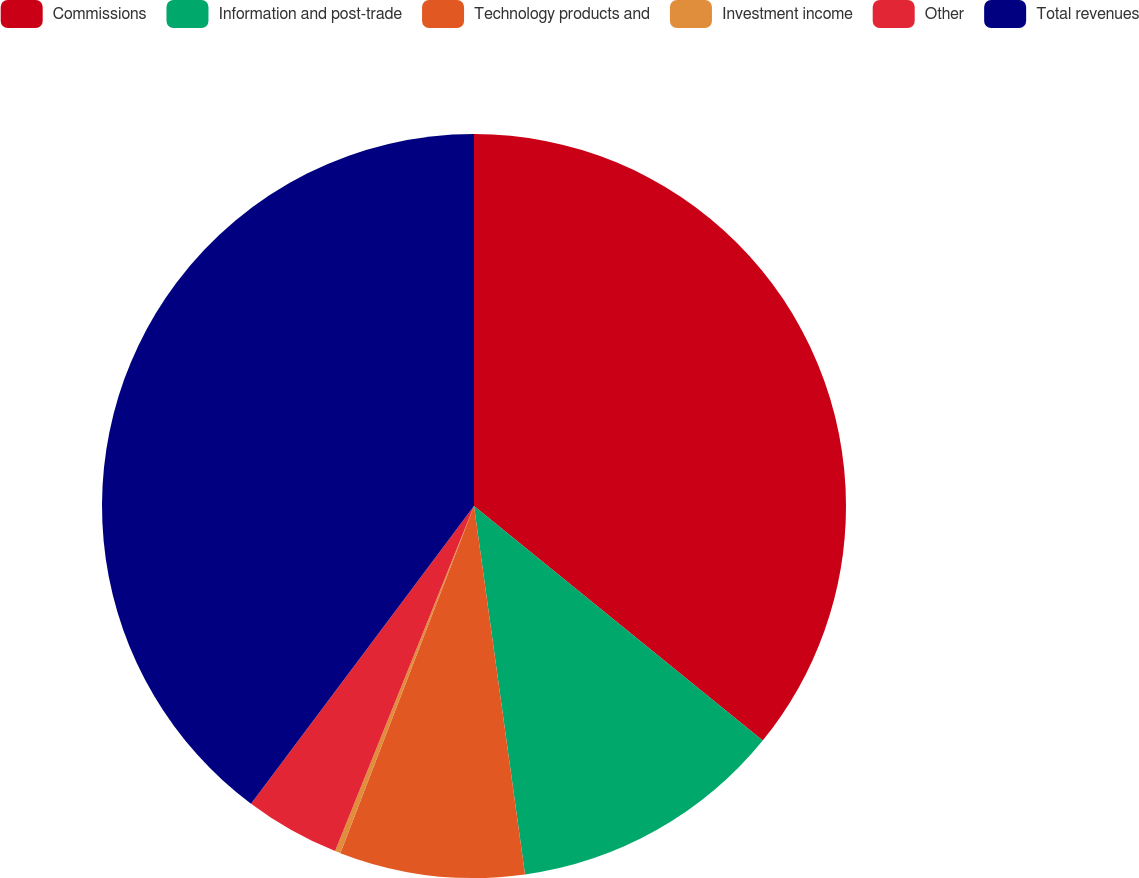<chart> <loc_0><loc_0><loc_500><loc_500><pie_chart><fcel>Commissions<fcel>Information and post-trade<fcel>Technology products and<fcel>Investment income<fcel>Other<fcel>Total revenues<nl><fcel>35.86%<fcel>11.95%<fcel>8.04%<fcel>0.24%<fcel>4.14%<fcel>39.77%<nl></chart> 